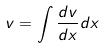<formula> <loc_0><loc_0><loc_500><loc_500>v = \int \frac { d v } { d x } d x</formula> 